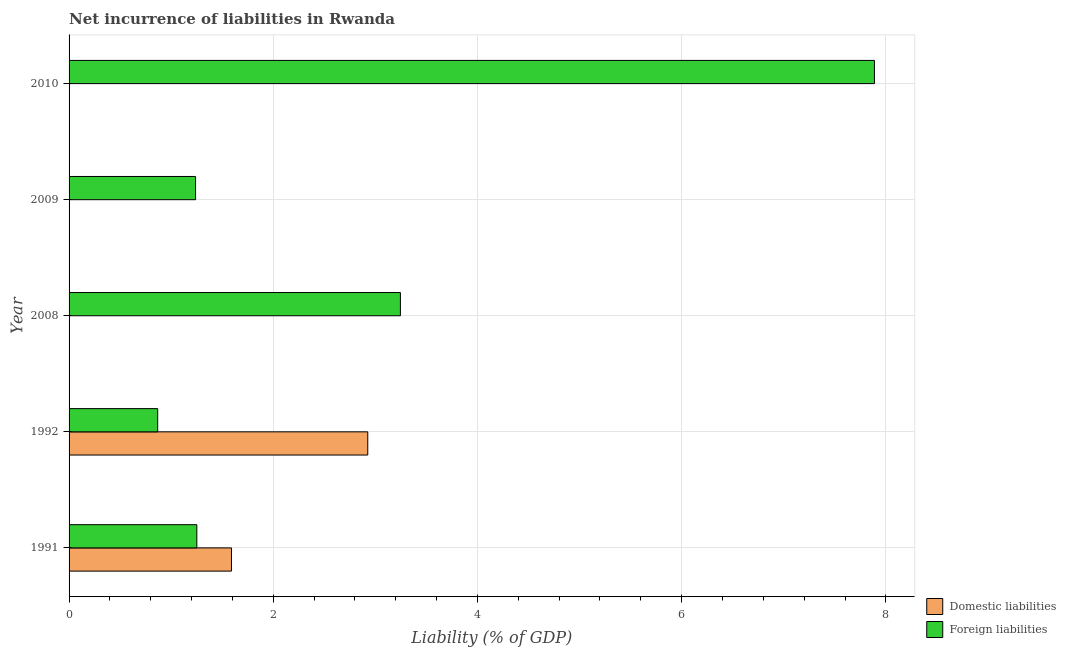Are the number of bars per tick equal to the number of legend labels?
Make the answer very short. No. Are the number of bars on each tick of the Y-axis equal?
Ensure brevity in your answer.  No. How many bars are there on the 4th tick from the bottom?
Provide a succinct answer. 1. What is the label of the 1st group of bars from the top?
Your response must be concise. 2010. In how many cases, is the number of bars for a given year not equal to the number of legend labels?
Your answer should be compact. 3. What is the incurrence of foreign liabilities in 2010?
Offer a terse response. 7.89. Across all years, what is the maximum incurrence of foreign liabilities?
Your response must be concise. 7.89. Across all years, what is the minimum incurrence of foreign liabilities?
Ensure brevity in your answer.  0.87. What is the total incurrence of foreign liabilities in the graph?
Ensure brevity in your answer.  14.49. What is the difference between the incurrence of foreign liabilities in 1991 and that in 2008?
Make the answer very short. -1.99. What is the difference between the incurrence of domestic liabilities in 2009 and the incurrence of foreign liabilities in 2010?
Your answer should be very brief. -7.89. What is the average incurrence of foreign liabilities per year?
Ensure brevity in your answer.  2.9. In the year 1991, what is the difference between the incurrence of domestic liabilities and incurrence of foreign liabilities?
Your response must be concise. 0.34. In how many years, is the incurrence of domestic liabilities greater than 2.8 %?
Make the answer very short. 1. What is the ratio of the incurrence of foreign liabilities in 1991 to that in 2010?
Offer a very short reply. 0.16. What is the difference between the highest and the second highest incurrence of foreign liabilities?
Ensure brevity in your answer.  4.64. What is the difference between the highest and the lowest incurrence of domestic liabilities?
Your response must be concise. 2.93. In how many years, is the incurrence of foreign liabilities greater than the average incurrence of foreign liabilities taken over all years?
Give a very brief answer. 2. Are all the bars in the graph horizontal?
Give a very brief answer. Yes. What is the difference between two consecutive major ticks on the X-axis?
Provide a succinct answer. 2. Are the values on the major ticks of X-axis written in scientific E-notation?
Give a very brief answer. No. Does the graph contain any zero values?
Your answer should be compact. Yes. Where does the legend appear in the graph?
Ensure brevity in your answer.  Bottom right. How are the legend labels stacked?
Offer a very short reply. Vertical. What is the title of the graph?
Your answer should be very brief. Net incurrence of liabilities in Rwanda. What is the label or title of the X-axis?
Offer a very short reply. Liability (% of GDP). What is the Liability (% of GDP) in Domestic liabilities in 1991?
Provide a succinct answer. 1.59. What is the Liability (% of GDP) of Foreign liabilities in 1991?
Offer a terse response. 1.25. What is the Liability (% of GDP) in Domestic liabilities in 1992?
Offer a terse response. 2.93. What is the Liability (% of GDP) in Foreign liabilities in 1992?
Your answer should be very brief. 0.87. What is the Liability (% of GDP) of Domestic liabilities in 2008?
Offer a very short reply. 0. What is the Liability (% of GDP) of Foreign liabilities in 2008?
Provide a succinct answer. 3.25. What is the Liability (% of GDP) of Foreign liabilities in 2009?
Ensure brevity in your answer.  1.24. What is the Liability (% of GDP) in Foreign liabilities in 2010?
Keep it short and to the point. 7.89. Across all years, what is the maximum Liability (% of GDP) in Domestic liabilities?
Offer a very short reply. 2.93. Across all years, what is the maximum Liability (% of GDP) in Foreign liabilities?
Your answer should be compact. 7.89. Across all years, what is the minimum Liability (% of GDP) of Domestic liabilities?
Your response must be concise. 0. Across all years, what is the minimum Liability (% of GDP) in Foreign liabilities?
Provide a short and direct response. 0.87. What is the total Liability (% of GDP) in Domestic liabilities in the graph?
Your answer should be compact. 4.52. What is the total Liability (% of GDP) of Foreign liabilities in the graph?
Make the answer very short. 14.49. What is the difference between the Liability (% of GDP) of Domestic liabilities in 1991 and that in 1992?
Keep it short and to the point. -1.33. What is the difference between the Liability (% of GDP) in Foreign liabilities in 1991 and that in 1992?
Provide a short and direct response. 0.38. What is the difference between the Liability (% of GDP) of Foreign liabilities in 1991 and that in 2008?
Provide a succinct answer. -1.99. What is the difference between the Liability (% of GDP) in Foreign liabilities in 1991 and that in 2009?
Ensure brevity in your answer.  0.01. What is the difference between the Liability (% of GDP) in Foreign liabilities in 1991 and that in 2010?
Keep it short and to the point. -6.64. What is the difference between the Liability (% of GDP) of Foreign liabilities in 1992 and that in 2008?
Provide a succinct answer. -2.38. What is the difference between the Liability (% of GDP) of Foreign liabilities in 1992 and that in 2009?
Provide a short and direct response. -0.37. What is the difference between the Liability (% of GDP) in Foreign liabilities in 1992 and that in 2010?
Provide a short and direct response. -7.02. What is the difference between the Liability (% of GDP) of Foreign liabilities in 2008 and that in 2009?
Make the answer very short. 2.01. What is the difference between the Liability (% of GDP) in Foreign liabilities in 2008 and that in 2010?
Ensure brevity in your answer.  -4.64. What is the difference between the Liability (% of GDP) of Foreign liabilities in 2009 and that in 2010?
Your answer should be compact. -6.65. What is the difference between the Liability (% of GDP) in Domestic liabilities in 1991 and the Liability (% of GDP) in Foreign liabilities in 1992?
Give a very brief answer. 0.72. What is the difference between the Liability (% of GDP) of Domestic liabilities in 1991 and the Liability (% of GDP) of Foreign liabilities in 2008?
Offer a terse response. -1.65. What is the difference between the Liability (% of GDP) of Domestic liabilities in 1991 and the Liability (% of GDP) of Foreign liabilities in 2009?
Keep it short and to the point. 0.35. What is the difference between the Liability (% of GDP) of Domestic liabilities in 1991 and the Liability (% of GDP) of Foreign liabilities in 2010?
Make the answer very short. -6.3. What is the difference between the Liability (% of GDP) in Domestic liabilities in 1992 and the Liability (% of GDP) in Foreign liabilities in 2008?
Offer a very short reply. -0.32. What is the difference between the Liability (% of GDP) in Domestic liabilities in 1992 and the Liability (% of GDP) in Foreign liabilities in 2009?
Your answer should be compact. 1.69. What is the difference between the Liability (% of GDP) in Domestic liabilities in 1992 and the Liability (% of GDP) in Foreign liabilities in 2010?
Provide a short and direct response. -4.96. What is the average Liability (% of GDP) in Domestic liabilities per year?
Keep it short and to the point. 0.9. What is the average Liability (% of GDP) in Foreign liabilities per year?
Make the answer very short. 2.9. In the year 1991, what is the difference between the Liability (% of GDP) of Domestic liabilities and Liability (% of GDP) of Foreign liabilities?
Keep it short and to the point. 0.34. In the year 1992, what is the difference between the Liability (% of GDP) of Domestic liabilities and Liability (% of GDP) of Foreign liabilities?
Make the answer very short. 2.06. What is the ratio of the Liability (% of GDP) of Domestic liabilities in 1991 to that in 1992?
Offer a very short reply. 0.54. What is the ratio of the Liability (% of GDP) of Foreign liabilities in 1991 to that in 1992?
Your answer should be very brief. 1.44. What is the ratio of the Liability (% of GDP) in Foreign liabilities in 1991 to that in 2008?
Offer a terse response. 0.39. What is the ratio of the Liability (% of GDP) in Foreign liabilities in 1991 to that in 2009?
Your answer should be compact. 1.01. What is the ratio of the Liability (% of GDP) in Foreign liabilities in 1991 to that in 2010?
Your answer should be very brief. 0.16. What is the ratio of the Liability (% of GDP) of Foreign liabilities in 1992 to that in 2008?
Keep it short and to the point. 0.27. What is the ratio of the Liability (% of GDP) in Foreign liabilities in 1992 to that in 2009?
Ensure brevity in your answer.  0.7. What is the ratio of the Liability (% of GDP) in Foreign liabilities in 1992 to that in 2010?
Provide a succinct answer. 0.11. What is the ratio of the Liability (% of GDP) of Foreign liabilities in 2008 to that in 2009?
Offer a terse response. 2.62. What is the ratio of the Liability (% of GDP) of Foreign liabilities in 2008 to that in 2010?
Make the answer very short. 0.41. What is the ratio of the Liability (% of GDP) in Foreign liabilities in 2009 to that in 2010?
Your answer should be very brief. 0.16. What is the difference between the highest and the second highest Liability (% of GDP) of Foreign liabilities?
Offer a very short reply. 4.64. What is the difference between the highest and the lowest Liability (% of GDP) in Domestic liabilities?
Your answer should be very brief. 2.93. What is the difference between the highest and the lowest Liability (% of GDP) of Foreign liabilities?
Keep it short and to the point. 7.02. 